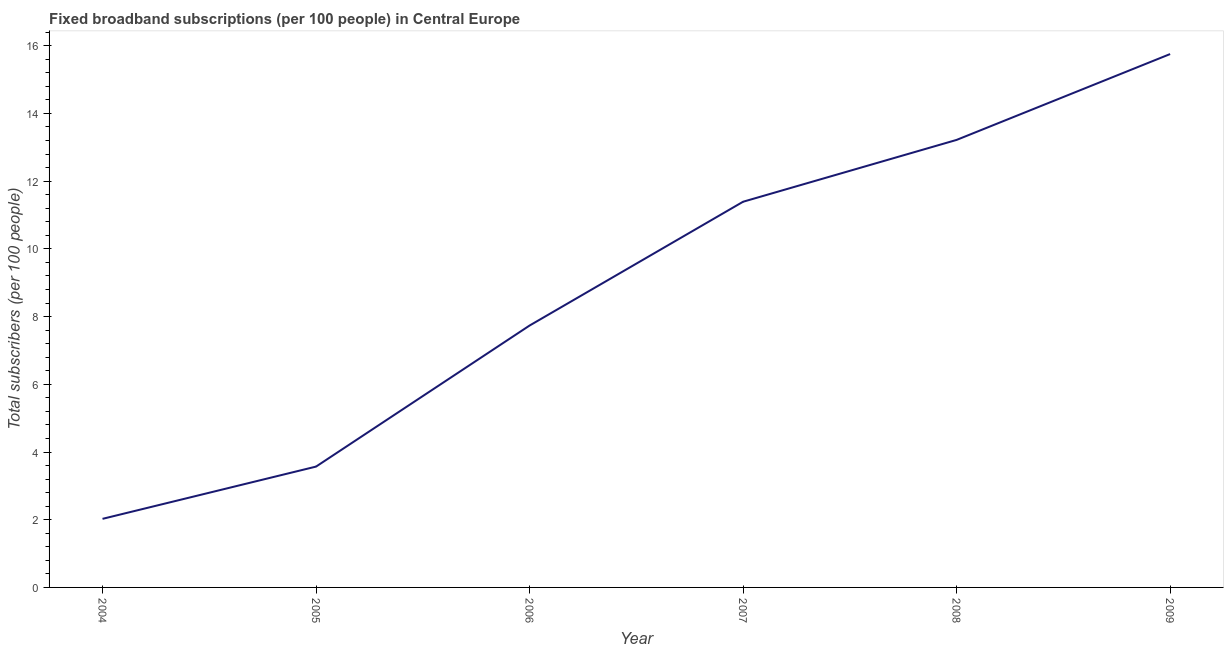What is the total number of fixed broadband subscriptions in 2009?
Keep it short and to the point. 15.75. Across all years, what is the maximum total number of fixed broadband subscriptions?
Your response must be concise. 15.75. Across all years, what is the minimum total number of fixed broadband subscriptions?
Make the answer very short. 2.03. In which year was the total number of fixed broadband subscriptions maximum?
Your answer should be very brief. 2009. What is the sum of the total number of fixed broadband subscriptions?
Your response must be concise. 53.69. What is the difference between the total number of fixed broadband subscriptions in 2004 and 2007?
Provide a short and direct response. -9.37. What is the average total number of fixed broadband subscriptions per year?
Your answer should be very brief. 8.95. What is the median total number of fixed broadband subscriptions?
Your answer should be compact. 9.56. In how many years, is the total number of fixed broadband subscriptions greater than 12.8 ?
Offer a very short reply. 2. What is the ratio of the total number of fixed broadband subscriptions in 2008 to that in 2009?
Your response must be concise. 0.84. What is the difference between the highest and the second highest total number of fixed broadband subscriptions?
Provide a succinct answer. 2.54. What is the difference between the highest and the lowest total number of fixed broadband subscriptions?
Make the answer very short. 13.73. Does the total number of fixed broadband subscriptions monotonically increase over the years?
Provide a succinct answer. Yes. How many years are there in the graph?
Your response must be concise. 6. What is the difference between two consecutive major ticks on the Y-axis?
Your response must be concise. 2. Does the graph contain any zero values?
Your answer should be compact. No. What is the title of the graph?
Your answer should be compact. Fixed broadband subscriptions (per 100 people) in Central Europe. What is the label or title of the Y-axis?
Offer a terse response. Total subscribers (per 100 people). What is the Total subscribers (per 100 people) of 2004?
Your answer should be compact. 2.03. What is the Total subscribers (per 100 people) in 2005?
Your answer should be compact. 3.57. What is the Total subscribers (per 100 people) in 2006?
Your response must be concise. 7.73. What is the Total subscribers (per 100 people) of 2007?
Ensure brevity in your answer.  11.39. What is the Total subscribers (per 100 people) in 2008?
Give a very brief answer. 13.22. What is the Total subscribers (per 100 people) of 2009?
Your answer should be compact. 15.75. What is the difference between the Total subscribers (per 100 people) in 2004 and 2005?
Make the answer very short. -1.54. What is the difference between the Total subscribers (per 100 people) in 2004 and 2006?
Ensure brevity in your answer.  -5.71. What is the difference between the Total subscribers (per 100 people) in 2004 and 2007?
Your response must be concise. -9.37. What is the difference between the Total subscribers (per 100 people) in 2004 and 2008?
Your response must be concise. -11.19. What is the difference between the Total subscribers (per 100 people) in 2004 and 2009?
Provide a succinct answer. -13.73. What is the difference between the Total subscribers (per 100 people) in 2005 and 2006?
Offer a very short reply. -4.17. What is the difference between the Total subscribers (per 100 people) in 2005 and 2007?
Give a very brief answer. -7.82. What is the difference between the Total subscribers (per 100 people) in 2005 and 2008?
Your answer should be compact. -9.65. What is the difference between the Total subscribers (per 100 people) in 2005 and 2009?
Give a very brief answer. -12.18. What is the difference between the Total subscribers (per 100 people) in 2006 and 2007?
Your answer should be compact. -3.66. What is the difference between the Total subscribers (per 100 people) in 2006 and 2008?
Give a very brief answer. -5.48. What is the difference between the Total subscribers (per 100 people) in 2006 and 2009?
Give a very brief answer. -8.02. What is the difference between the Total subscribers (per 100 people) in 2007 and 2008?
Keep it short and to the point. -1.83. What is the difference between the Total subscribers (per 100 people) in 2007 and 2009?
Offer a very short reply. -4.36. What is the difference between the Total subscribers (per 100 people) in 2008 and 2009?
Your answer should be very brief. -2.54. What is the ratio of the Total subscribers (per 100 people) in 2004 to that in 2005?
Your answer should be very brief. 0.57. What is the ratio of the Total subscribers (per 100 people) in 2004 to that in 2006?
Provide a succinct answer. 0.26. What is the ratio of the Total subscribers (per 100 people) in 2004 to that in 2007?
Ensure brevity in your answer.  0.18. What is the ratio of the Total subscribers (per 100 people) in 2004 to that in 2008?
Your answer should be compact. 0.15. What is the ratio of the Total subscribers (per 100 people) in 2004 to that in 2009?
Your response must be concise. 0.13. What is the ratio of the Total subscribers (per 100 people) in 2005 to that in 2006?
Ensure brevity in your answer.  0.46. What is the ratio of the Total subscribers (per 100 people) in 2005 to that in 2007?
Give a very brief answer. 0.31. What is the ratio of the Total subscribers (per 100 people) in 2005 to that in 2008?
Make the answer very short. 0.27. What is the ratio of the Total subscribers (per 100 people) in 2005 to that in 2009?
Keep it short and to the point. 0.23. What is the ratio of the Total subscribers (per 100 people) in 2006 to that in 2007?
Offer a terse response. 0.68. What is the ratio of the Total subscribers (per 100 people) in 2006 to that in 2008?
Your answer should be very brief. 0.58. What is the ratio of the Total subscribers (per 100 people) in 2006 to that in 2009?
Provide a short and direct response. 0.49. What is the ratio of the Total subscribers (per 100 people) in 2007 to that in 2008?
Keep it short and to the point. 0.86. What is the ratio of the Total subscribers (per 100 people) in 2007 to that in 2009?
Provide a succinct answer. 0.72. What is the ratio of the Total subscribers (per 100 people) in 2008 to that in 2009?
Ensure brevity in your answer.  0.84. 